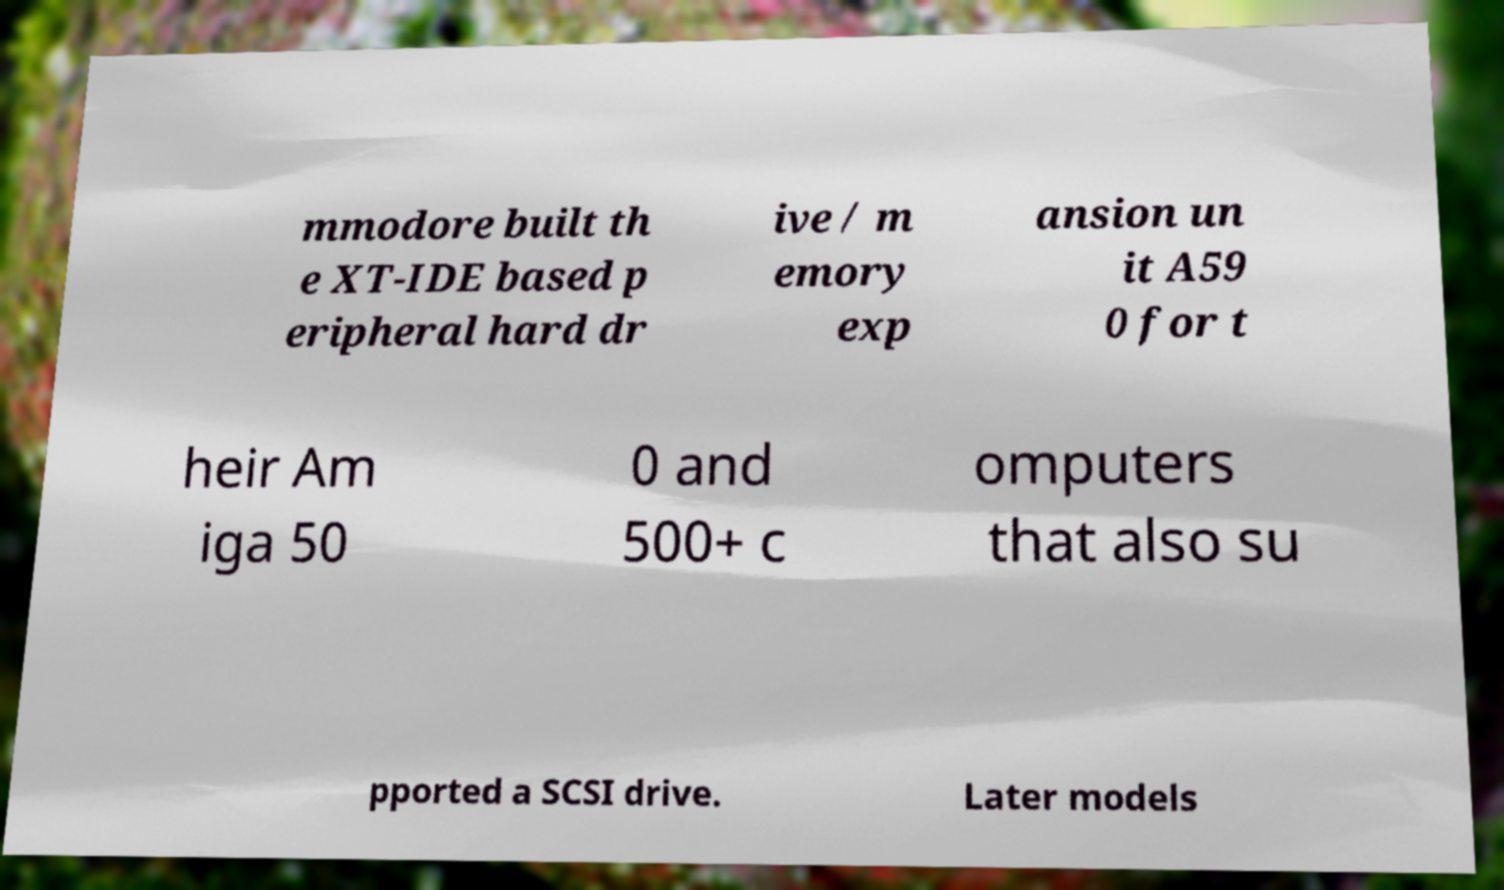What messages or text are displayed in this image? I need them in a readable, typed format. mmodore built th e XT-IDE based p eripheral hard dr ive / m emory exp ansion un it A59 0 for t heir Am iga 50 0 and 500+ c omputers that also su pported a SCSI drive. Later models 